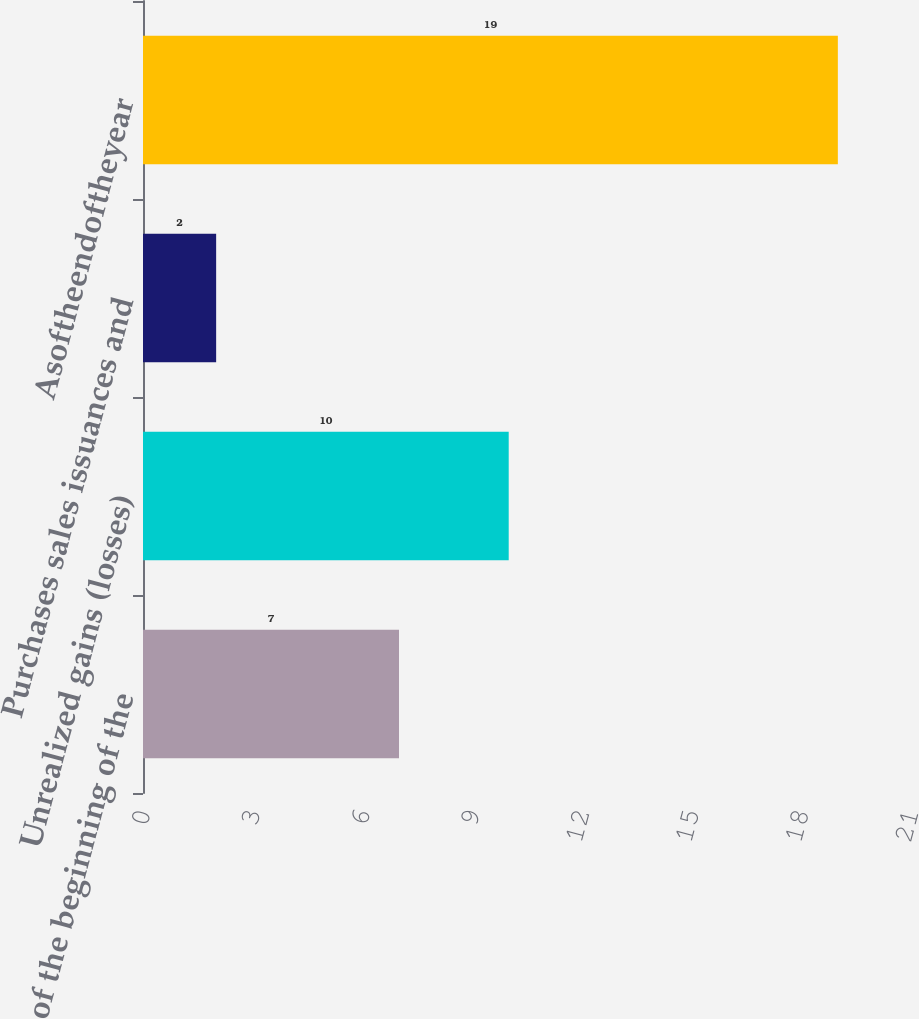Convert chart to OTSL. <chart><loc_0><loc_0><loc_500><loc_500><bar_chart><fcel>As of the beginning of the<fcel>Unrealized gains (losses)<fcel>Purchases sales issuances and<fcel>Asoftheendoftheyear<nl><fcel>7<fcel>10<fcel>2<fcel>19<nl></chart> 